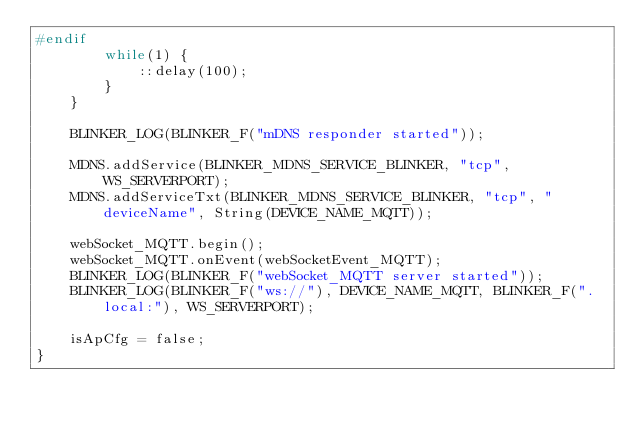Convert code to text. <code><loc_0><loc_0><loc_500><loc_500><_C_>#endif
        while(1) {
            ::delay(100);
        }
    }

    BLINKER_LOG(BLINKER_F("mDNS responder started"));

    MDNS.addService(BLINKER_MDNS_SERVICE_BLINKER, "tcp", WS_SERVERPORT);
    MDNS.addServiceTxt(BLINKER_MDNS_SERVICE_BLINKER, "tcp", "deviceName", String(DEVICE_NAME_MQTT));

    webSocket_MQTT.begin();
    webSocket_MQTT.onEvent(webSocketEvent_MQTT);
    BLINKER_LOG(BLINKER_F("webSocket_MQTT server started"));
    BLINKER_LOG(BLINKER_F("ws://"), DEVICE_NAME_MQTT, BLINKER_F(".local:"), WS_SERVERPORT);

    isApCfg = false;
}
</code> 